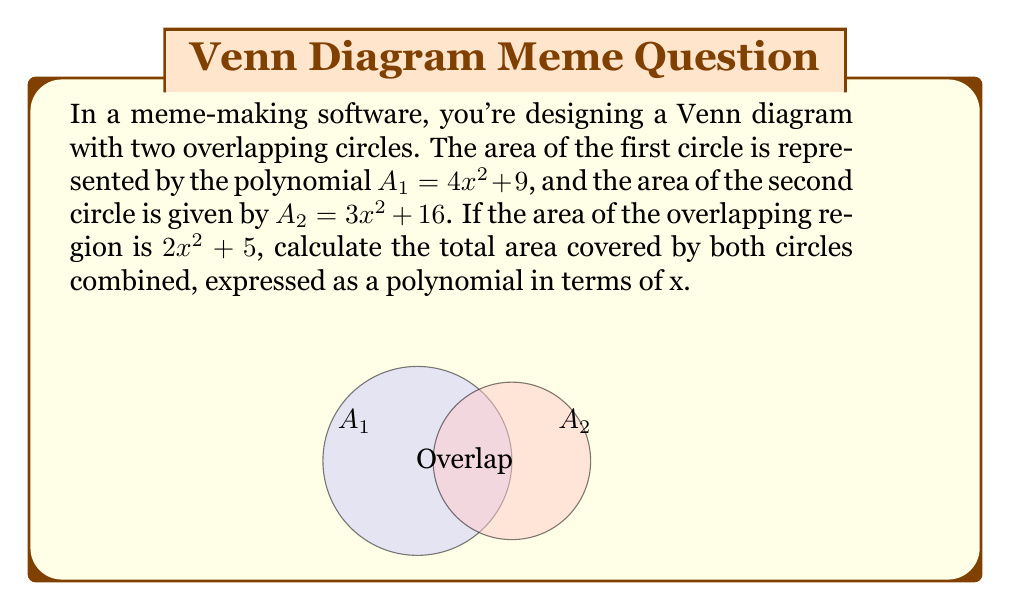Help me with this question. To solve this problem, we'll follow these steps:

1) First, let's recall the formula for the total area of two overlapping shapes:
   Total Area = Area of Shape 1 + Area of Shape 2 - Area of Overlap

2) We're given:
   $A_1 = 4x^2 + 9$ (Area of first circle)
   $A_2 = 3x^2 + 16$ (Area of second circle)
   Overlap Area = $2x^2 + 5$

3) Now, let's substitute these into our formula:
   Total Area = $(4x^2 + 9) + (3x^2 + 16) - (2x^2 + 5)$

4) Let's simplify by combining like terms:
   $= 4x^2 + 9 + 3x^2 + 16 - 2x^2 - 5$
   $= (4x^2 + 3x^2 - 2x^2) + (9 + 16 - 5)$
   $= 5x^2 + 20$

Thus, the total area covered by both circles is represented by the polynomial $5x^2 + 20$.
Answer: $5x^2 + 20$ 